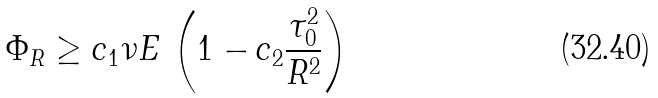Convert formula to latex. <formula><loc_0><loc_0><loc_500><loc_500>\Phi _ { R } \geq c _ { 1 } \nu E \, \left ( 1 - c _ { 2 } \frac { \tau _ { 0 } ^ { 2 } } { R ^ { 2 } } \right )</formula> 